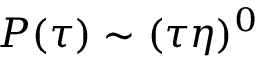<formula> <loc_0><loc_0><loc_500><loc_500>P ( \tau ) \sim ( \tau \eta ) ^ { 0 }</formula> 